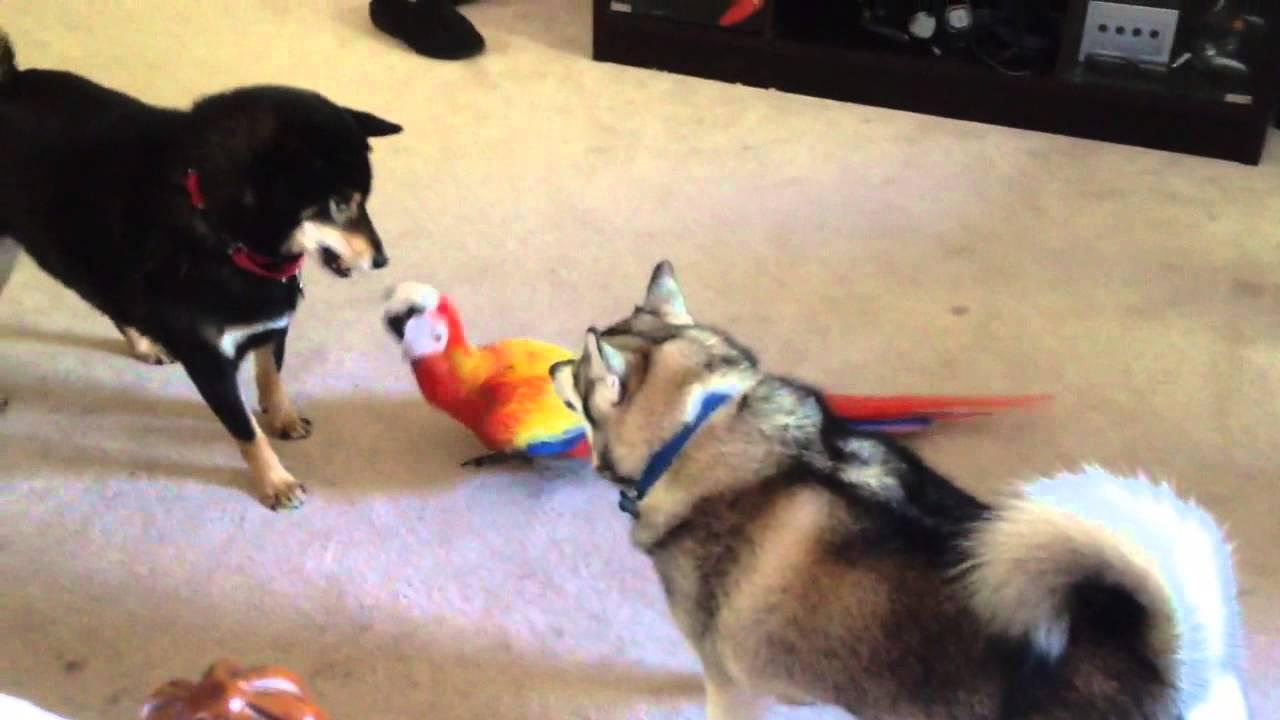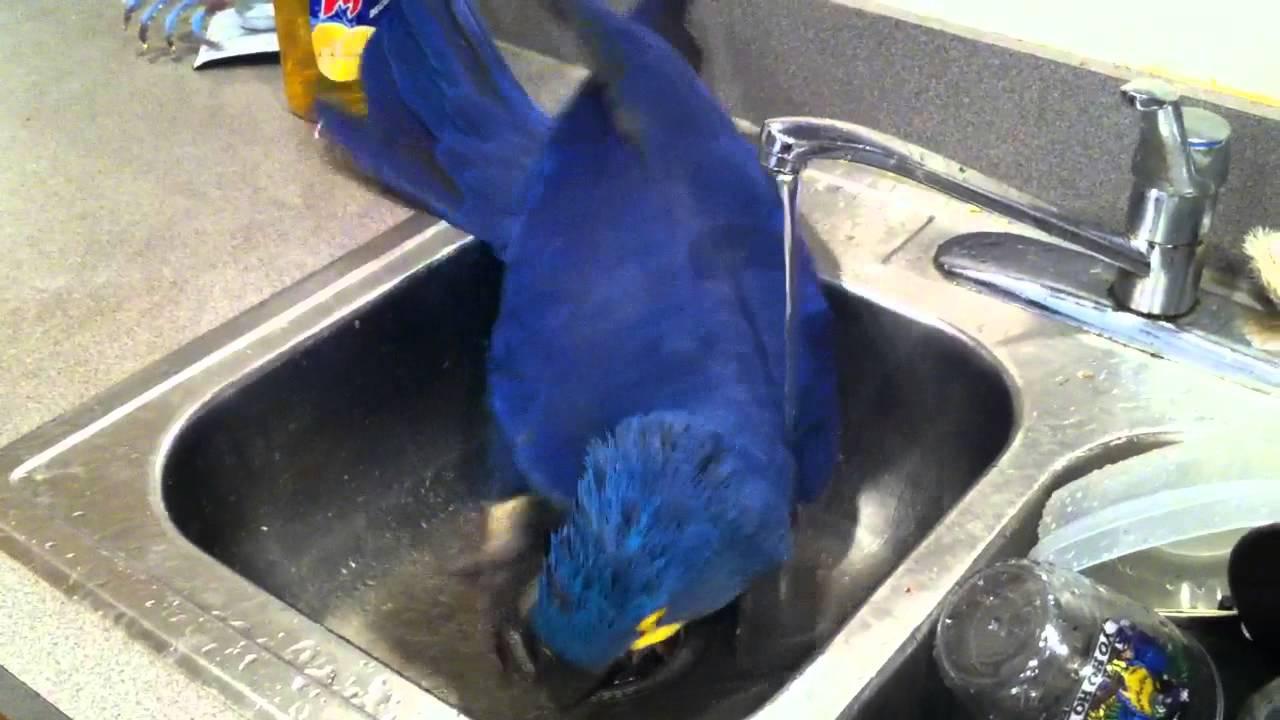The first image is the image on the left, the second image is the image on the right. For the images displayed, is the sentence "There is a human petting a bird in at least one of the images." factually correct? Answer yes or no. No. The first image is the image on the left, the second image is the image on the right. Evaluate the accuracy of this statement regarding the images: "At least one image shows a person touching a parrot that is on its back.". Is it true? Answer yes or no. No. 